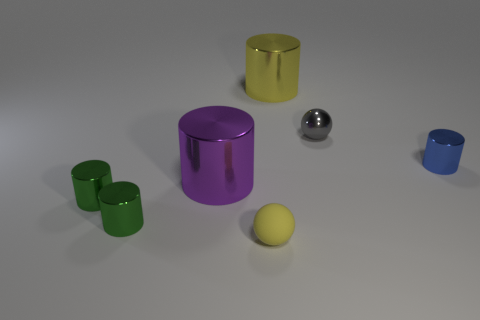What number of balls are either big yellow objects or large objects?
Make the answer very short. 0. What number of large purple objects are in front of the large shiny cylinder in front of the large shiny thing that is behind the big purple thing?
Make the answer very short. 0. What size is the cylinder that is the same color as the small rubber sphere?
Offer a terse response. Large. Are there any tiny yellow spheres that have the same material as the yellow cylinder?
Your answer should be compact. No. Does the blue cylinder have the same material as the purple thing?
Ensure brevity in your answer.  Yes. There is a small gray metal object that is right of the purple metallic thing; how many blue things are behind it?
Offer a terse response. 0. How many red things are small metal cylinders or tiny rubber balls?
Offer a very short reply. 0. The small object behind the small cylinder that is to the right of the sphere that is in front of the purple metal cylinder is what shape?
Offer a very short reply. Sphere. There is a metal ball that is the same size as the blue shiny object; what color is it?
Ensure brevity in your answer.  Gray. How many tiny blue metallic things are the same shape as the rubber object?
Make the answer very short. 0. 